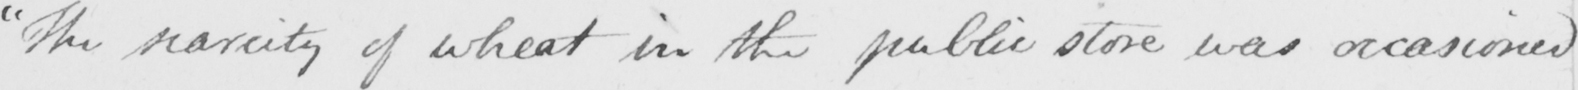Please transcribe the handwritten text in this image. " The scarcity of wheat in the public store was occasioned 